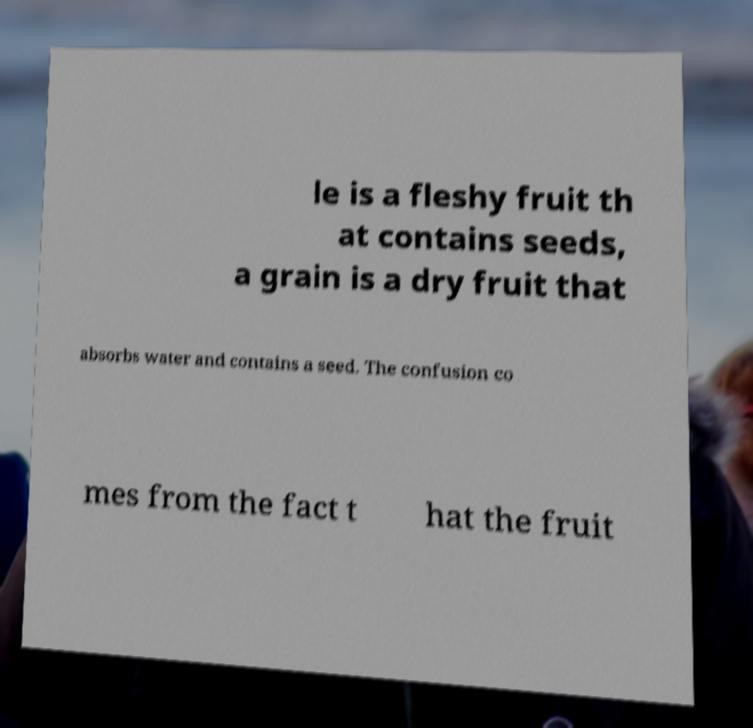Could you assist in decoding the text presented in this image and type it out clearly? le is a fleshy fruit th at contains seeds, a grain is a dry fruit that absorbs water and contains a seed. The confusion co mes from the fact t hat the fruit 